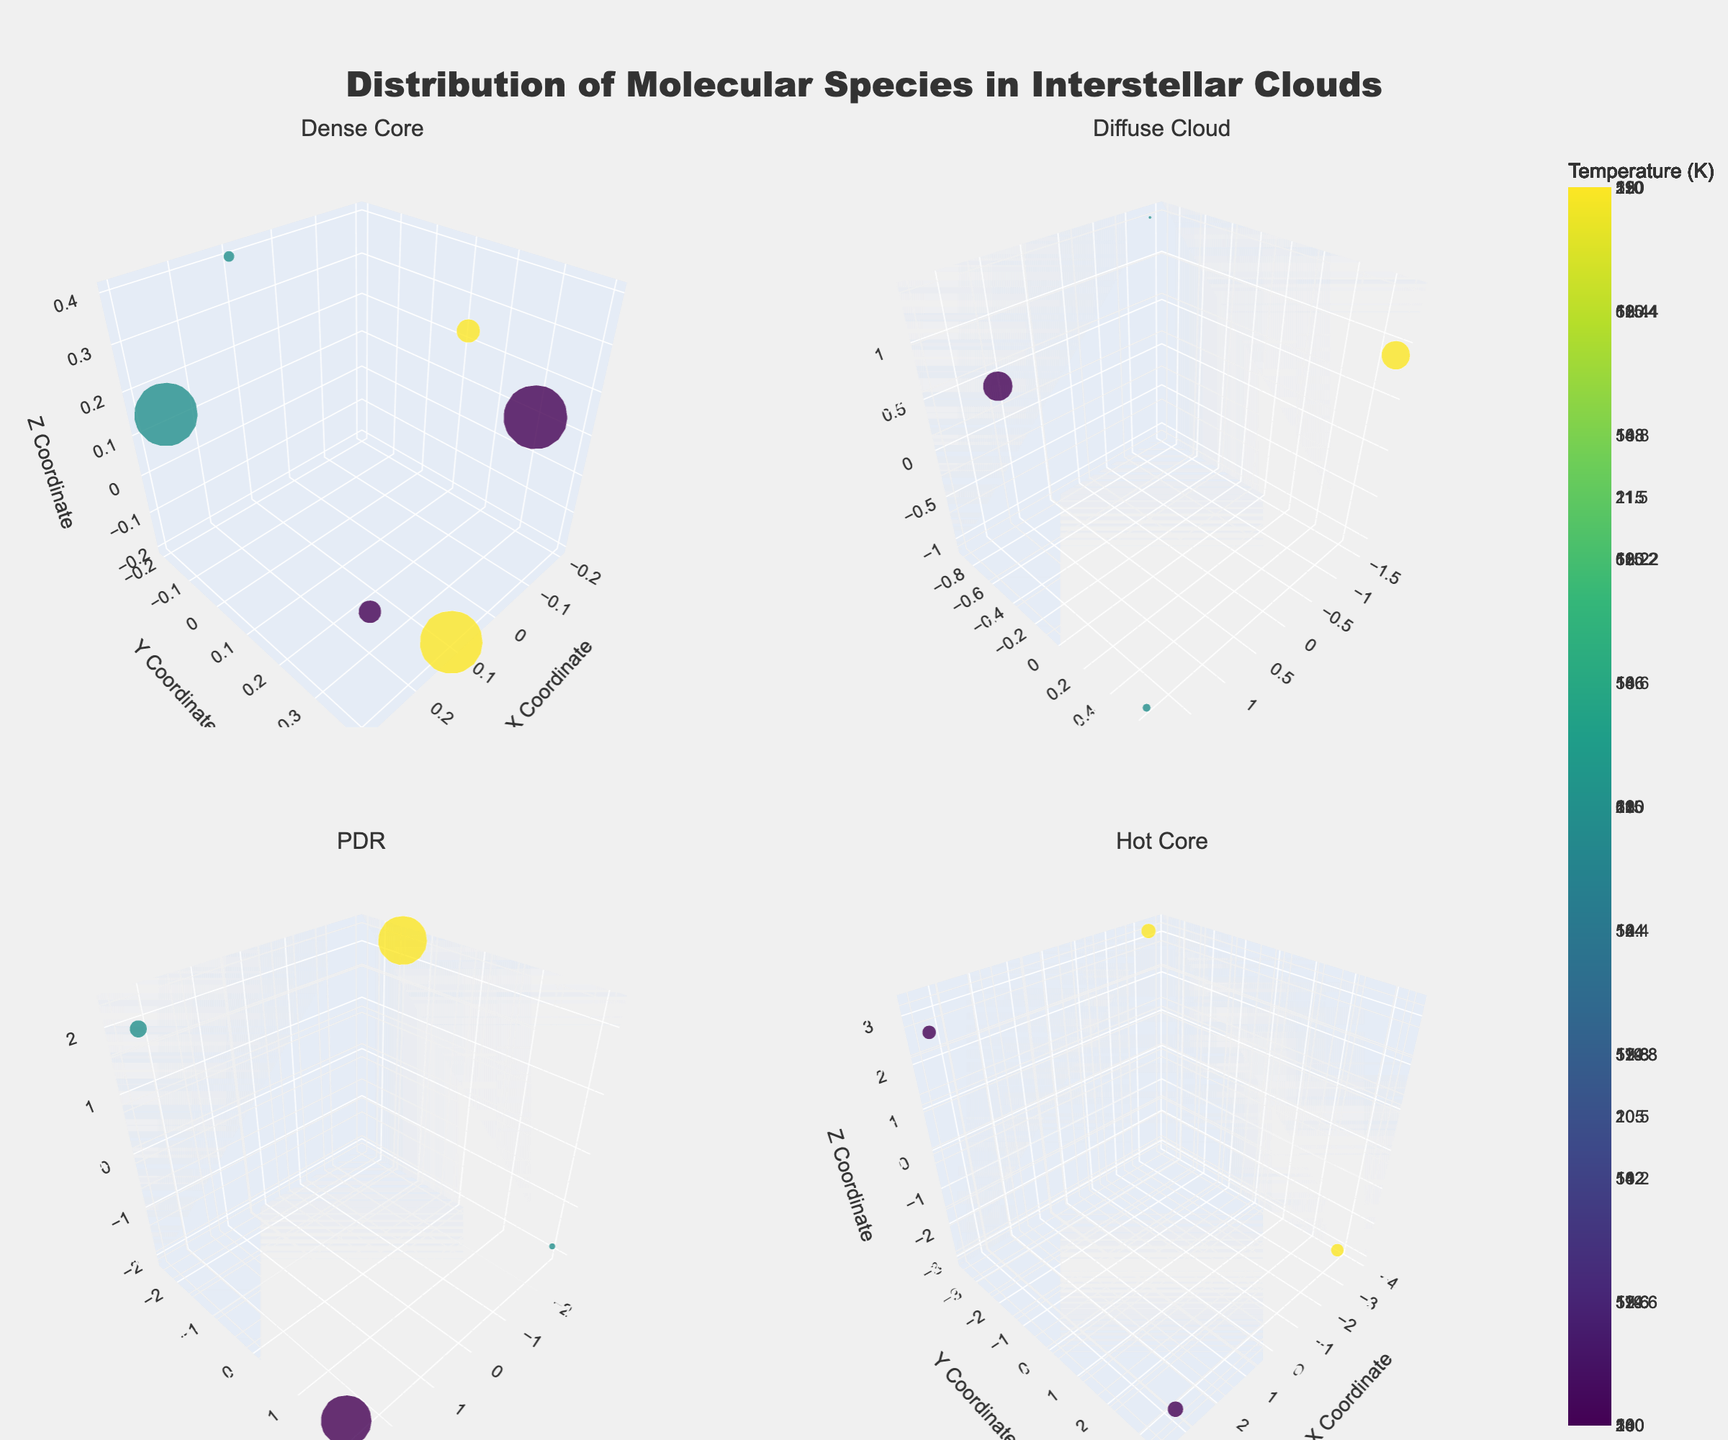Which region has the highest temperature for H2? In the subplot for each region, the color intensity represents the temperature for H2. By comparing the subplots, the PDR region shows the highest temperature for H2.
Answer: PDR What are the coordinates (x, y, z) of the HCN molecule in the Diffuse Cloud? In the subplot for the Diffuse Cloud, locate the marker for HCN. The coordinates given are (-1.3, -0.9, 1.4).
Answer: (-1.3, -0.9, 1.4) Which molecule in the Dense Core region has the highest density? In the subplot for Dense Core, the size of the markers represents density. The largest marker corresponds to H2 with a density of 1000.
Answer: H2 Compare the average temperatures of CO in Dense Core and Diffuse Cloud regions. Which is higher? First, observe the temperature values for CO in Dense Core and Diffuse Cloud. The average temperature for CO in Dense Core is (15+14)/2 = 14.5. In Diffuse Cloud, it's 60. Hence, Diffuse Cloud is higher.
Answer: Diffuse Cloud How does the spatial distribution of H2 differ between Diffuse Cloud and PDR regions? Examine the 3D positions of H2 in both regions. In Diffuse Cloud, markers are spread more irregularly, while in PDR, there is a more structured alignment.
Answer: Diffuse Cloud is more irregularly spread What is the temperature range for molecules in the Hot Core region? Look at the color scales for Hot Core molecules. The temperature ranges from 180 K to 220 K.
Answer: 180 K to 220 K Which region has the most diverse types of molecules based on this plot? Check each subplot for the number of distinct molecule markers. The Hot Core region shows the most diversity with two different molecules (CH and NH3).
Answer: Hot Core How many H2 molecules are there in total across all regions? Count the H2 markers by checking each subplot. There are 3 in Dense Core, 2 in Diffuse Cloud, and 2 in PDR, summing up to 7.
Answer: 7 List the regions with CH molecules and their respective temperatures. Find the markers for CH in the relevant subplots. CH appears in the Hot Core region with temperatures of 200 K and 220 K.
Answer: Hot Core, 200 K and 220 K 